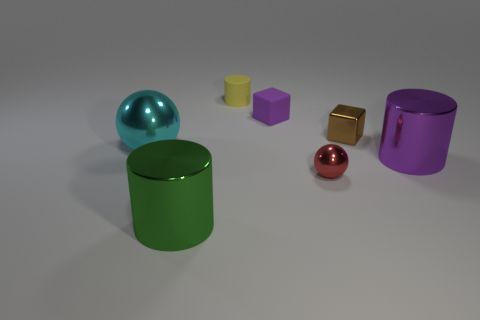Subtract all metal cylinders. How many cylinders are left? 1 Subtract 1 blocks. How many blocks are left? 1 Subtract all red spheres. How many spheres are left? 1 Add 2 tiny spheres. How many objects exist? 9 Subtract all purple cubes. How many cyan spheres are left? 1 Subtract 0 gray blocks. How many objects are left? 7 Subtract all spheres. How many objects are left? 5 Subtract all red cylinders. Subtract all blue spheres. How many cylinders are left? 3 Subtract all small yellow objects. Subtract all large green metallic things. How many objects are left? 5 Add 7 cyan shiny balls. How many cyan shiny balls are left? 8 